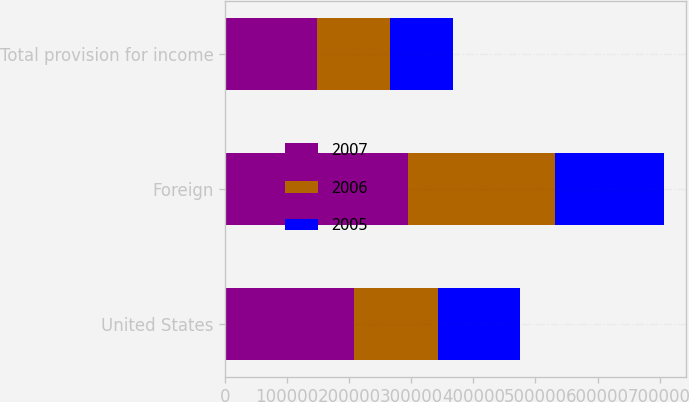Convert chart to OTSL. <chart><loc_0><loc_0><loc_500><loc_500><stacked_bar_chart><ecel><fcel>United States<fcel>Foreign<fcel>Total provision for income<nl><fcel>2007<fcel>206922<fcel>294062<fcel>147790<nl><fcel>2006<fcel>135904<fcel>237368<fcel>117581<nl><fcel>2005<fcel>132715<fcel>175253<fcel>101629<nl></chart> 